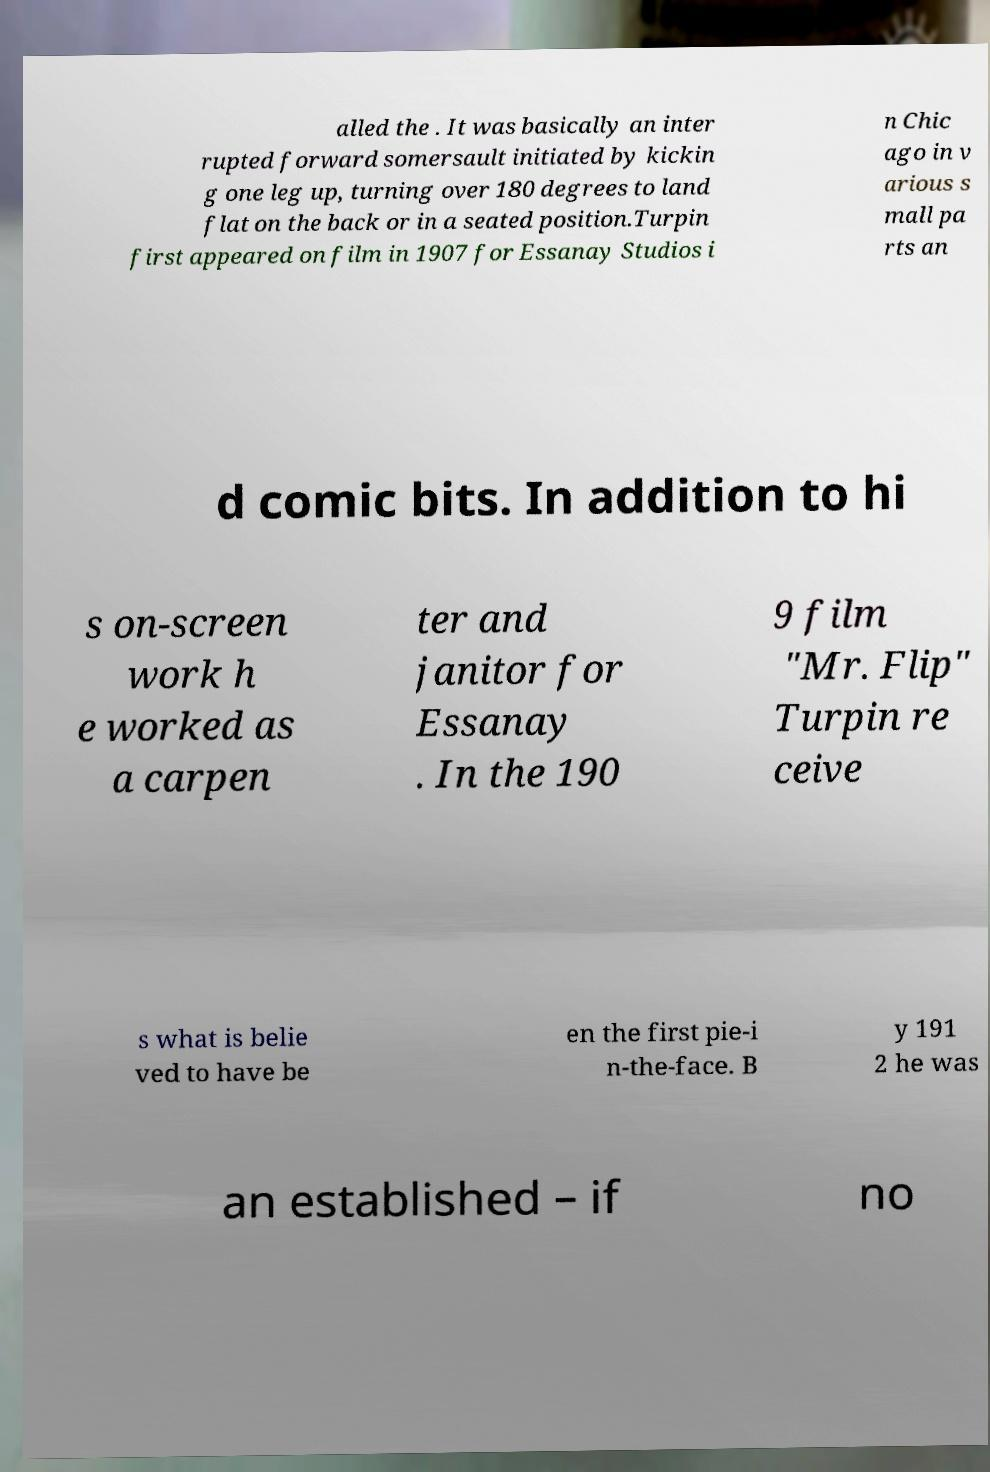Please read and relay the text visible in this image. What does it say? alled the . It was basically an inter rupted forward somersault initiated by kickin g one leg up, turning over 180 degrees to land flat on the back or in a seated position.Turpin first appeared on film in 1907 for Essanay Studios i n Chic ago in v arious s mall pa rts an d comic bits. In addition to hi s on-screen work h e worked as a carpen ter and janitor for Essanay . In the 190 9 film "Mr. Flip" Turpin re ceive s what is belie ved to have be en the first pie-i n-the-face. B y 191 2 he was an established – if no 